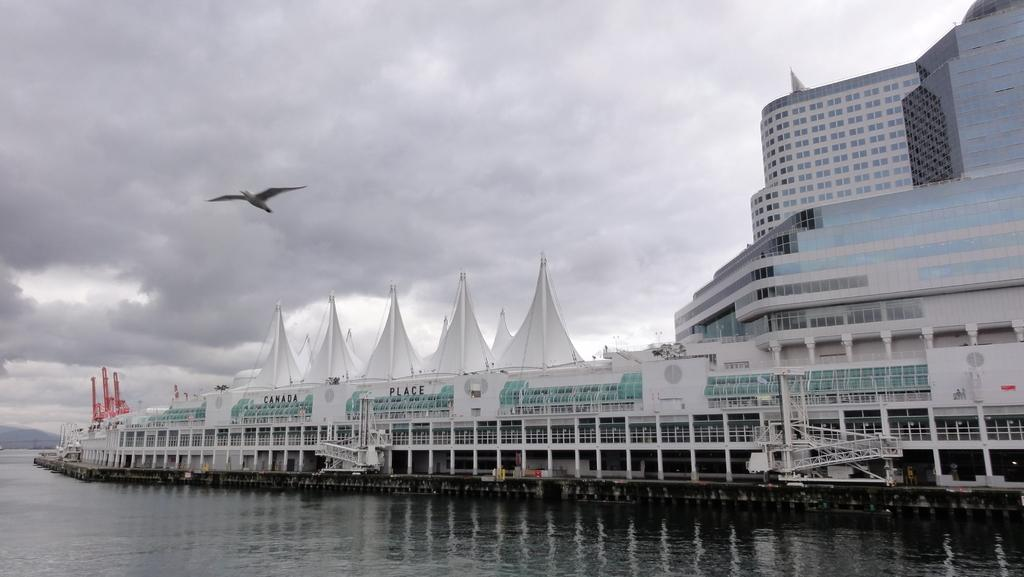What type of structures can be seen in the image? There are buildings in the image. What natural element is visible in the image? There is water visible in the image. What type of animal is present in the image? There is a bird in the image. What is visible in the background of the image? The sky is visible in the background of the image. What is the weather like in the image? The sky appears to be cloudy, suggesting a potentially overcast or rainy day. Where is the girl playing with a bucket in the image? There is no girl or bucket present in the image. What type of shell does the snail have in the image? There is no snail present in the image. 